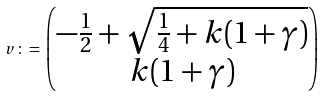<formula> <loc_0><loc_0><loc_500><loc_500>v \, \colon = \, \begin{pmatrix} - \frac { 1 } { 2 } + \sqrt { \frac { 1 } { 4 } + k ( 1 + \gamma ) } \\ k ( 1 + \gamma ) \end{pmatrix}</formula> 